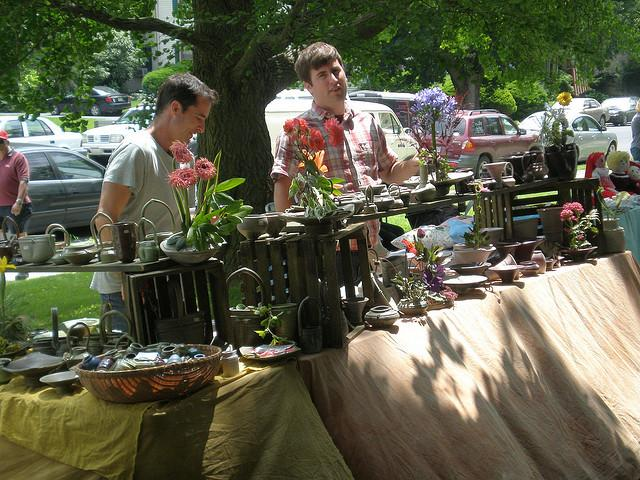What items are being shown off most frequently here?

Choices:
A) door knobs
B) green plants
C) boxes
D) pottery pottery 